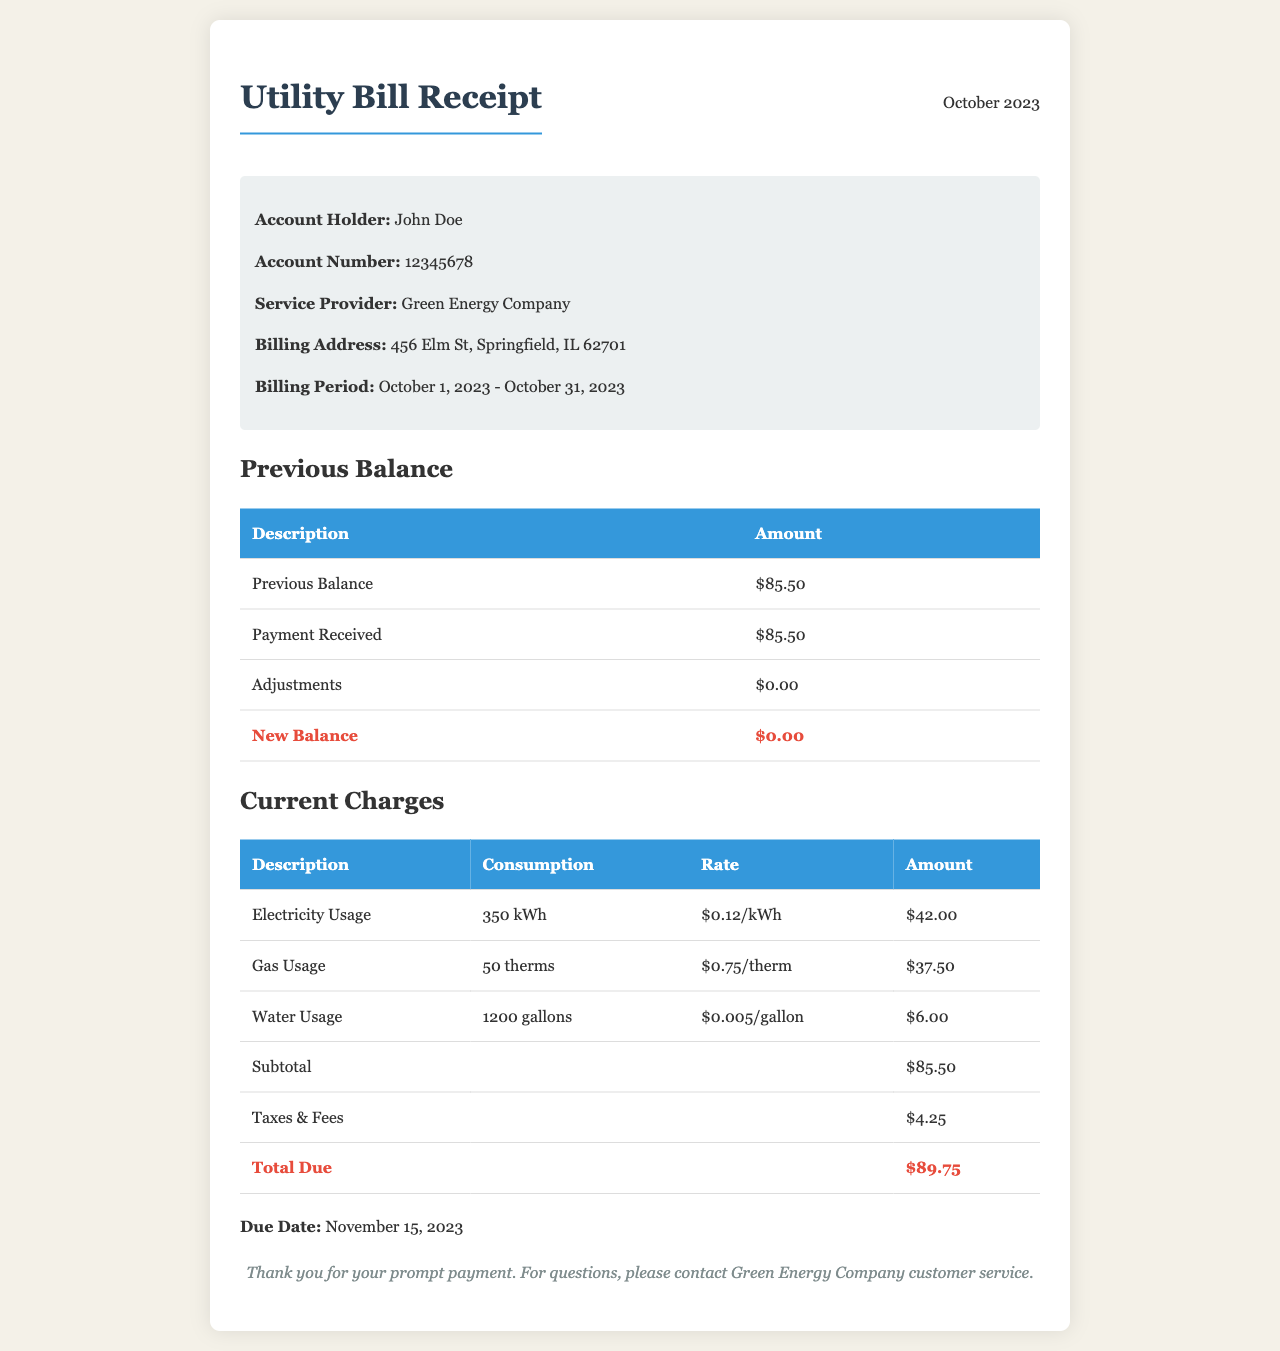What is the account holder's name? The account holder's name is stated in the account information section of the document.
Answer: John Doe What is the service provider's name? The name of the service provider is mentioned in the account information section.
Answer: Green Energy Company What is the previous balance amount? The previous balance amount is listed under the previous balance section of the document.
Answer: $85.50 What is the total due? The total due is clearly specified at the bottom of the current charges section.
Answer: $89.75 What is the due date for payment? The due date is provided in a designated section at the end of the document.
Answer: November 15, 2023 How much was paid from the previous balance? The amount received from the previous balance is mentioned in the table for previous balance.
Answer: $85.50 What is the consumption of electricity in this bill? The consumption of electricity is indicated in the current charges section of the document.
Answer: 350 kWh What is the rate for gas usage? The rate for gas usage is specified in the current charges table.
Answer: $0.75/therm What is the total amount for taxes and fees? The total for taxes and fees is listed under the current charges section.
Answer: $4.25 